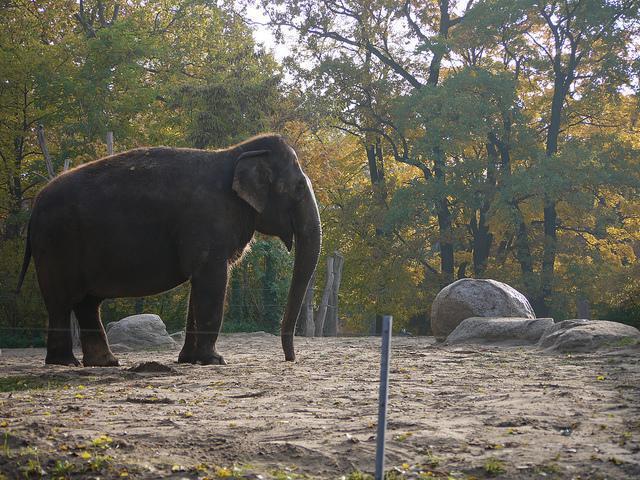How many types of animals are represented?
Give a very brief answer. 1. 